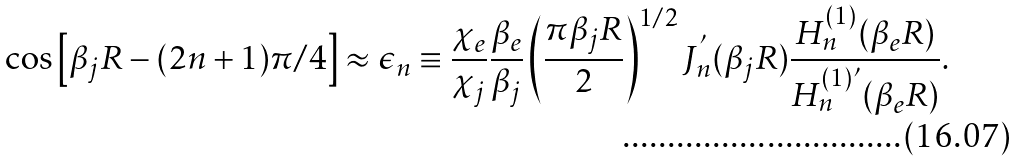Convert formula to latex. <formula><loc_0><loc_0><loc_500><loc_500>\cos \left [ \beta _ { j } R - ( 2 n + 1 ) \pi / 4 \right ] \approx \epsilon _ { n } \equiv \frac { \chi _ { e } } { \chi _ { j } } \frac { \beta _ { e } } { \beta _ { j } } \left ( \frac { \pi \beta _ { j } R } { 2 } \right ) ^ { 1 / 2 } J _ { n } ^ { ^ { \prime } } ( \beta _ { j } R ) \frac { H _ { n } ^ { ( 1 ) } ( \beta _ { e } R ) } { H _ { n } ^ { ( 1 ) ^ { \prime } } ( \beta _ { e } R ) } .</formula> 